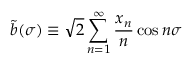Convert formula to latex. <formula><loc_0><loc_0><loc_500><loc_500>\tilde { b } ( \sigma ) \equiv \sqrt { 2 } \sum _ { n = 1 } ^ { \infty } \frac { x _ { n } } { n } \cos n \sigma</formula> 